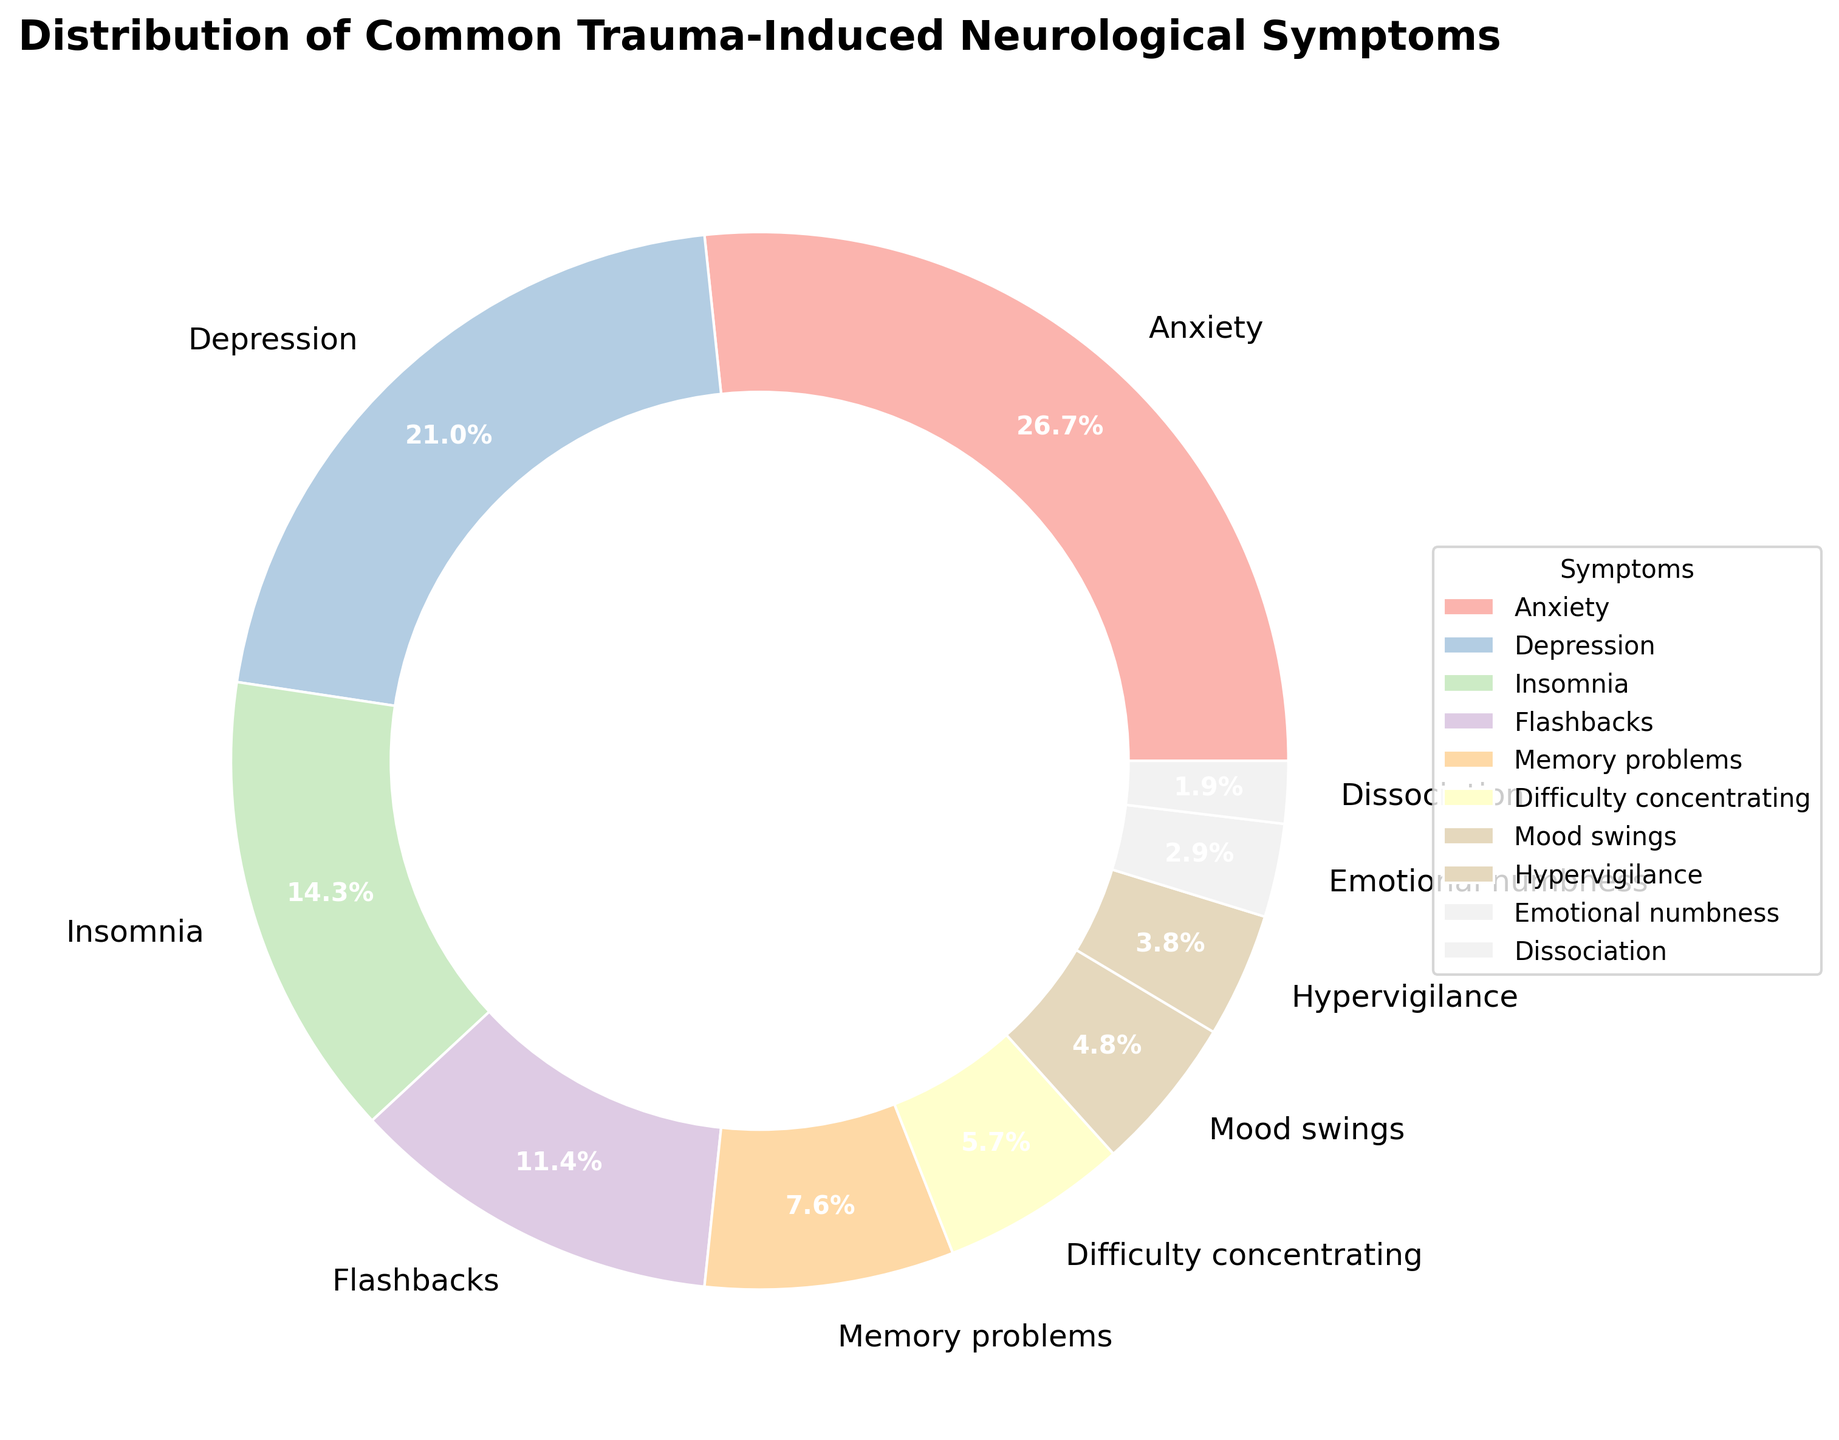What is the most common trauma-induced neurological symptom? The largest wedge in the pie chart is labeled as ‘Anxiety’ with a percentage of 28%. This indicates that Anxiety is the most common symptom.
Answer: Anxiety Which symptom has a higher percentage, Insomnia or Flashbacks? Looking at the respective wedges, Insomnia has a percentage of 15%, while Flashbacks have a percentage of 12%. 15% is greater than 12%.
Answer: Insomnia What is the combined percentage of Mood swings and Emotional numbness? Mood swings have a percentage of 5% and Emotional numbness has 3%. Adding these together, 5% + 3% = 8%.
Answer: 8% Which symptom is least common according to the chart? The smallest wedge in the pie chart is labeled as ‘Dissociation’ with a percentage of 2%. Therefore, Dissociation is the least common symptom.
Answer: Dissociation Is the percentage of Anxiety greater than the combined percentage of Hypervigilance and Emotional numbness? The percentage of Anxiety is 28%. The combined percentage of Hypervigilance (4%) and Emotional numbness (3%) is 4% + 3% = 7%. Comparing these, 28% is greater than 7%.
Answer: Yes What two symptoms together make up more than 50% of the distribution? The two largest wedges in the pie chart are Anxiety (28%) and Depression (22%). Adding these together, 28% + 22% = 50%. Therefore, no two symptoms together make up more than 50%.
Answer: None Which is more prevalent: Memory problems or Difficulty concentrating? Memory problems have a percentage of 8%, and Difficulty concentrating has 6%. Hence, Memory problems are more prevalent.
Answer: Memory problems Are Flashbacks more common than Mood swings? Flashbacks have a percentage of 12%, while Mood swings have a percentage of 5%. Since 12% is greater than 5%, Flashbacks are more common.
Answer: Yes What is the sum of the percentages of the bottom three symptoms? The bottom three symptoms by percentage are Emotional numbness (3%), Dissociation (2%), and Hypervigilance (4%). Adding these together: 3% + 2% + 4% = 9%.
Answer: 9% How does the percentage of Depression compare to Insomnia and Flashbacks combined? Depression has a percentage of 22%. Adding the percentages of Insomnia (15%) and Flashbacks (12%) gives 15% + 12% = 27%. Thus, Depression (22%) is less than Insomnia and Flashbacks combined (27%).
Answer: Less 